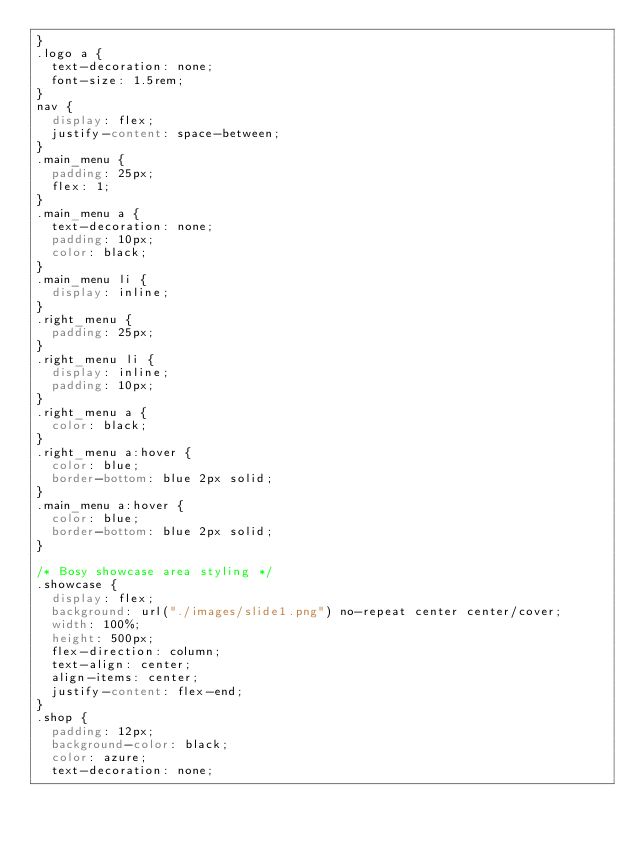<code> <loc_0><loc_0><loc_500><loc_500><_CSS_>}
.logo a {
  text-decoration: none;
  font-size: 1.5rem;
}
nav {
  display: flex;
  justify-content: space-between;
}
.main_menu {
  padding: 25px;
  flex: 1;
}
.main_menu a {
  text-decoration: none;
  padding: 10px;
  color: black;
}
.main_menu li {
  display: inline;
}
.right_menu {
  padding: 25px;
}
.right_menu li {
  display: inline;
  padding: 10px;
}
.right_menu a {
  color: black;
}
.right_menu a:hover {
  color: blue;
  border-bottom: blue 2px solid;
}
.main_menu a:hover {
  color: blue;
  border-bottom: blue 2px solid;
}

/* Bosy showcase area styling */
.showcase {
  display: flex;
  background: url("./images/slide1.png") no-repeat center center/cover;
  width: 100%;
  height: 500px;
  flex-direction: column;
  text-align: center;
  align-items: center;
  justify-content: flex-end;
}
.shop {
  padding: 12px;
  background-color: black;
  color: azure;
  text-decoration: none;</code> 